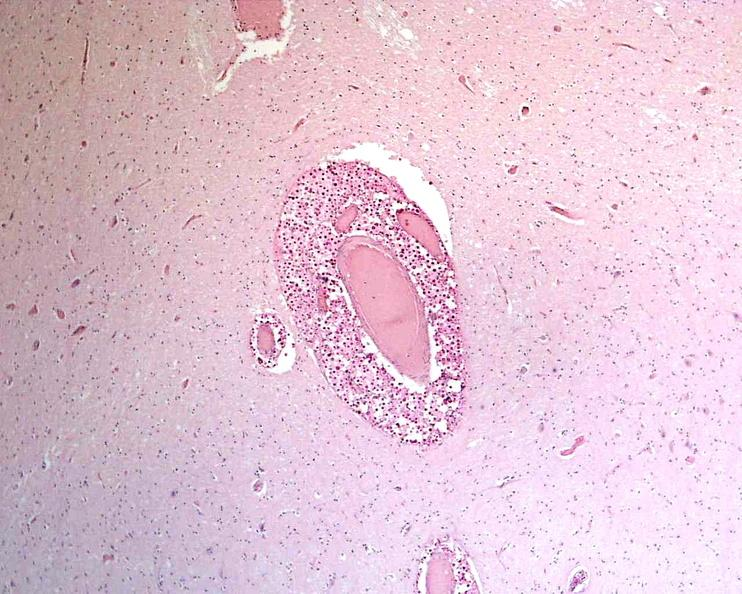what is present?
Answer the question using a single word or phrase. Nervous 